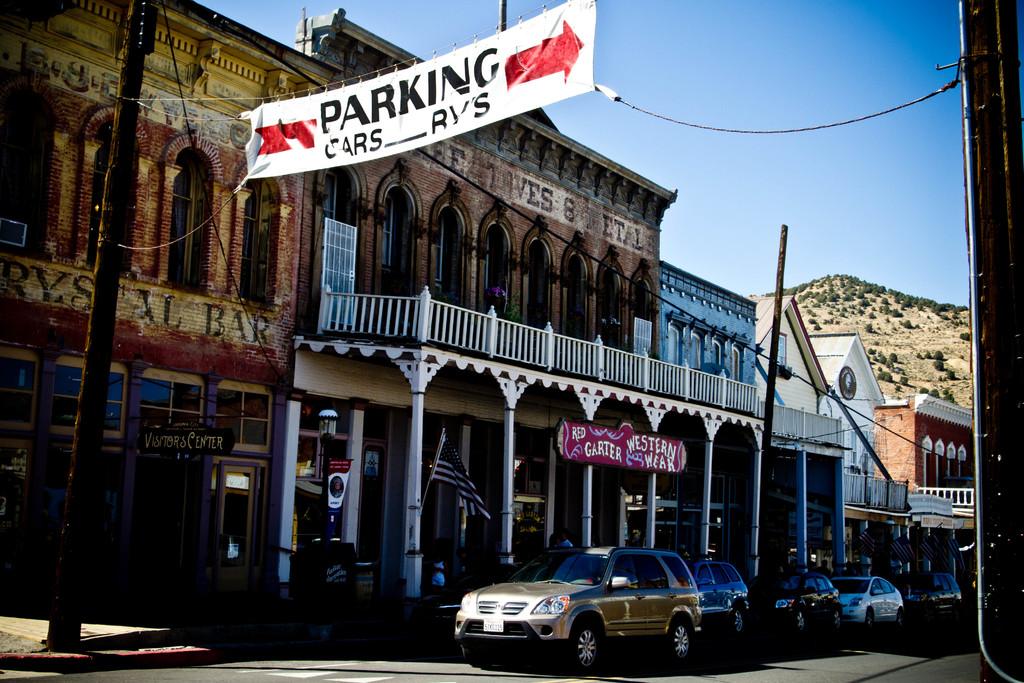What direction is parking in?
Make the answer very short. Right. What does it say you can park besides cars?
Your response must be concise. Rvs. 